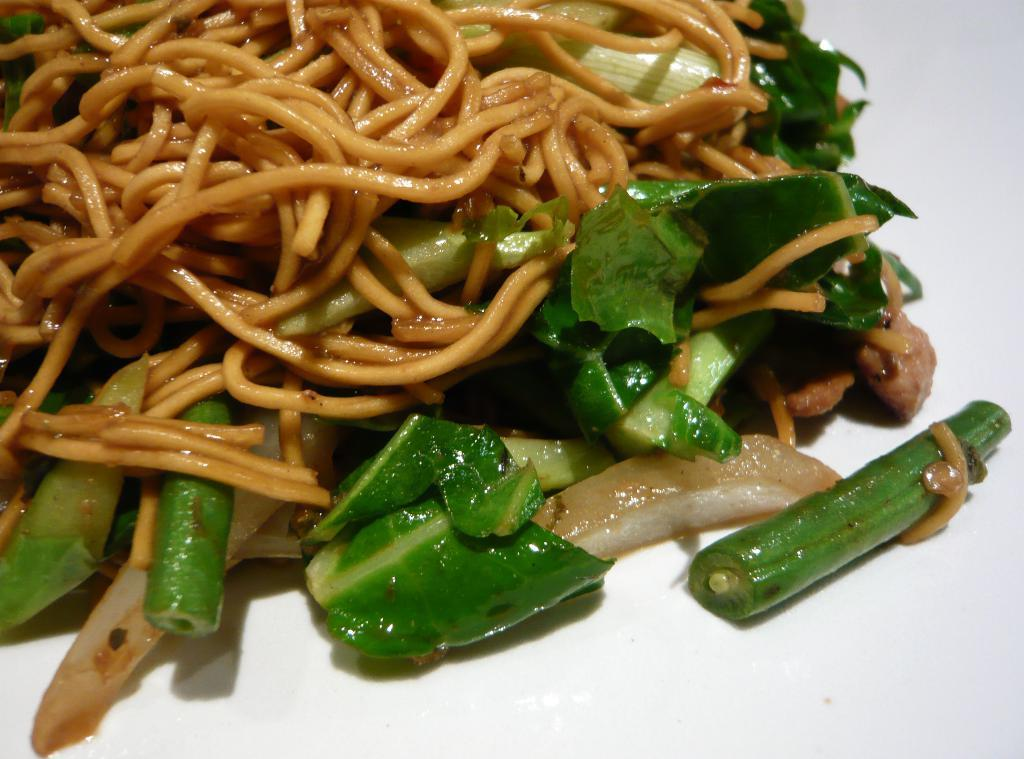What type of items can be seen in the image? The image contains food. Can you tell me how many flights are visible in the image? There are no flights visible in the image, as it contains food and not any transportation-related objects. 